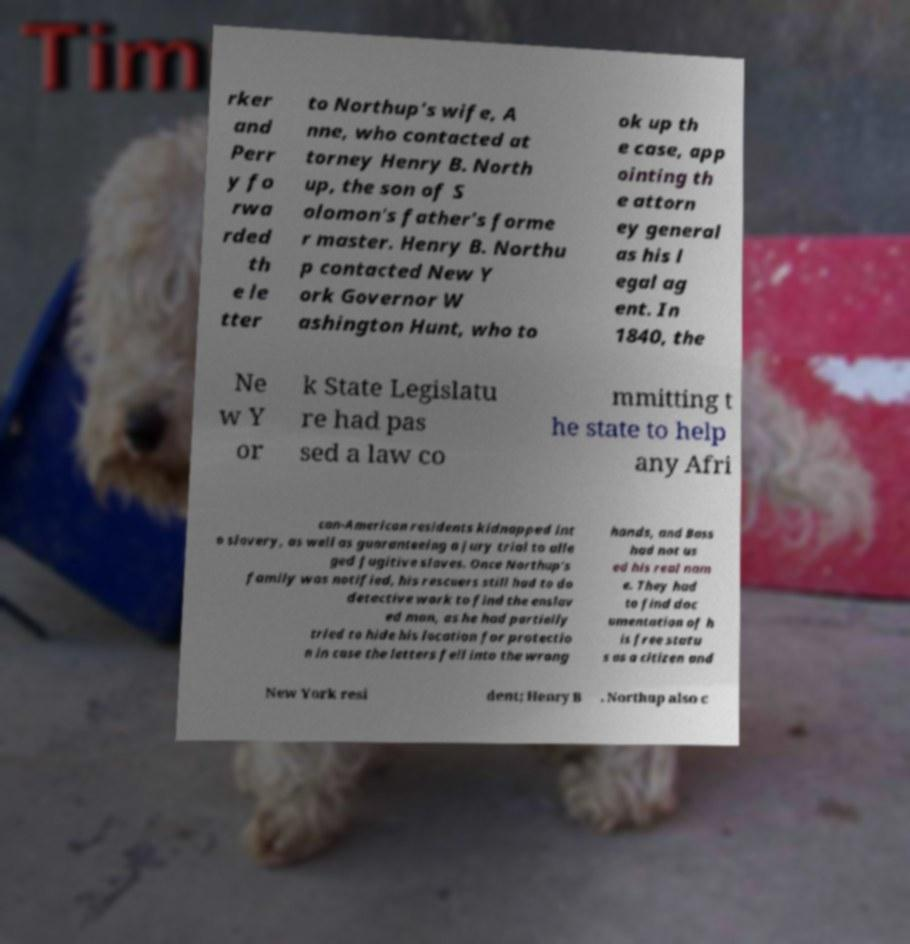Could you extract and type out the text from this image? rker and Perr y fo rwa rded th e le tter to Northup's wife, A nne, who contacted at torney Henry B. North up, the son of S olomon's father's forme r master. Henry B. Northu p contacted New Y ork Governor W ashington Hunt, who to ok up th e case, app ointing th e attorn ey general as his l egal ag ent. In 1840, the Ne w Y or k State Legislatu re had pas sed a law co mmitting t he state to help any Afri can-American residents kidnapped int o slavery, as well as guaranteeing a jury trial to alle ged fugitive slaves. Once Northup's family was notified, his rescuers still had to do detective work to find the enslav ed man, as he had partially tried to hide his location for protectio n in case the letters fell into the wrong hands, and Bass had not us ed his real nam e. They had to find doc umentation of h is free statu s as a citizen and New York resi dent; Henry B . Northup also c 